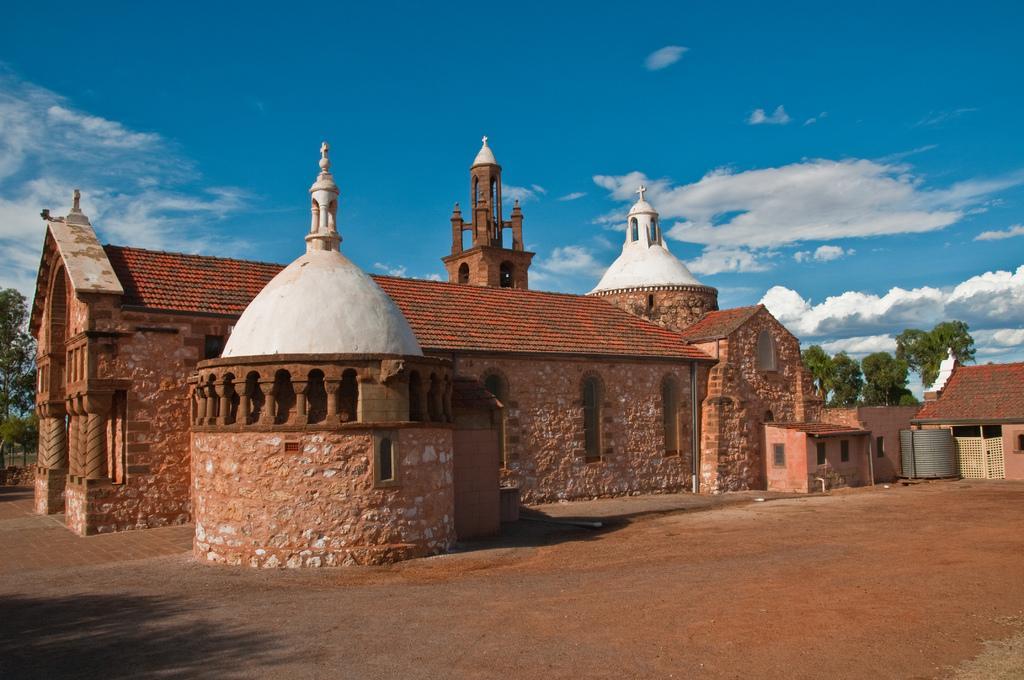Please provide a concise description of this image. In this picture we can see house, in the background there are trees, we can see the sky at the top of the picture. 